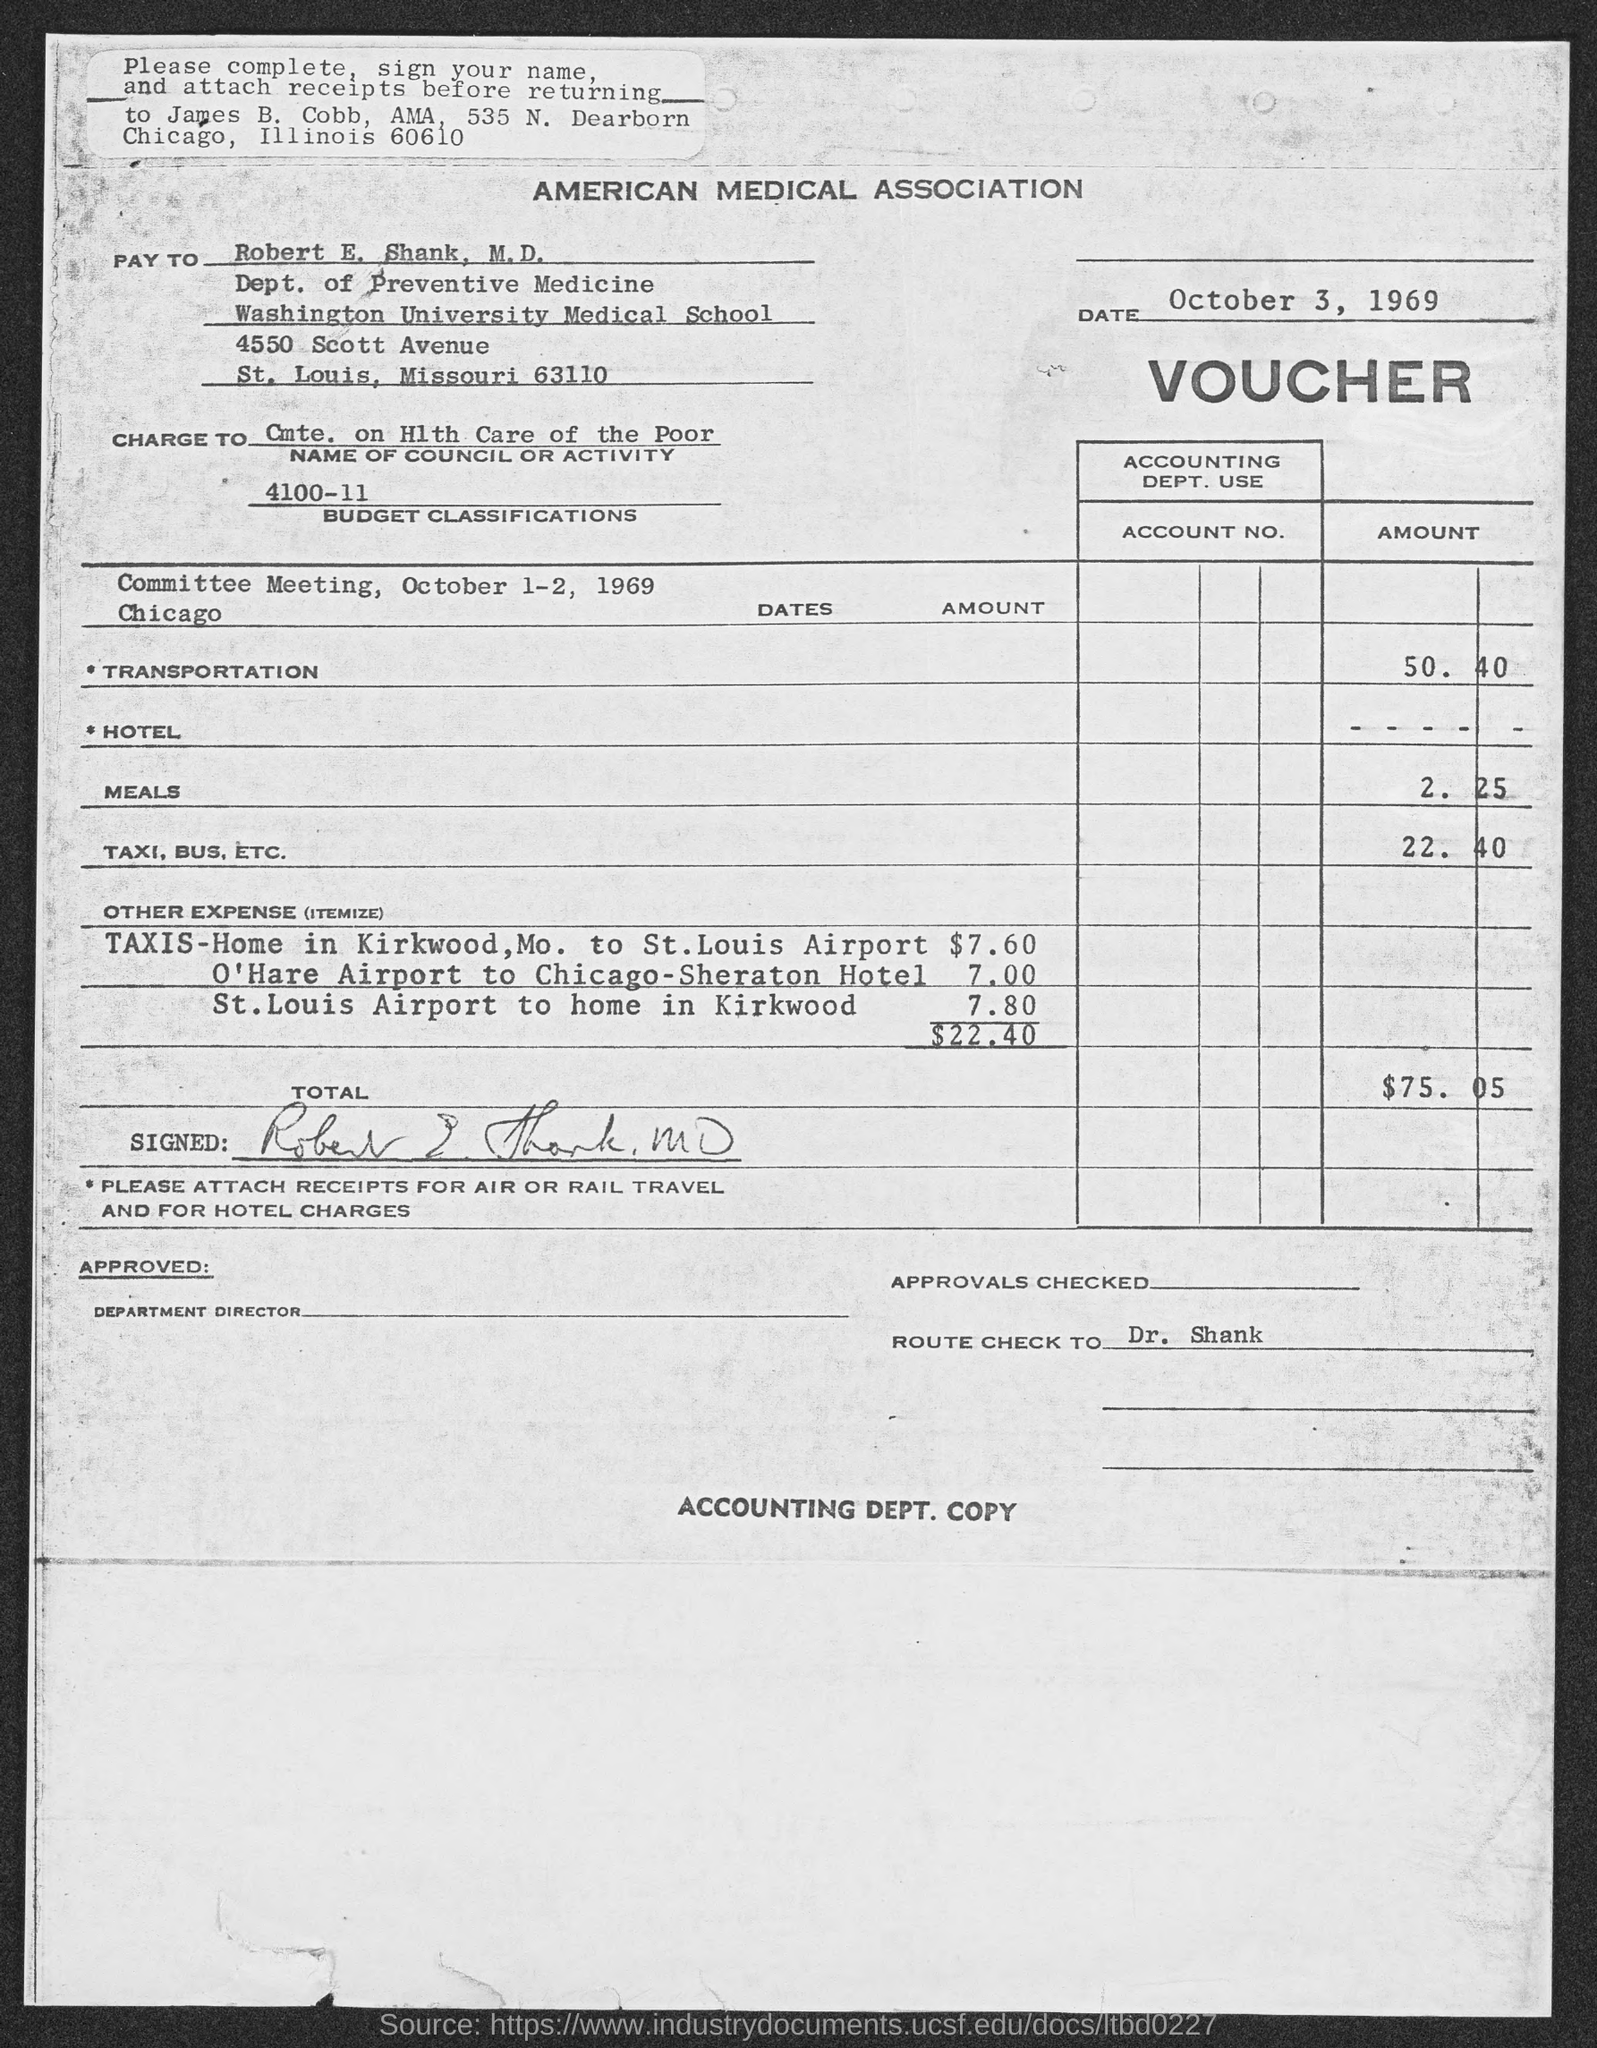In which state is washington university medical school at?
Keep it short and to the point. Missouri. 